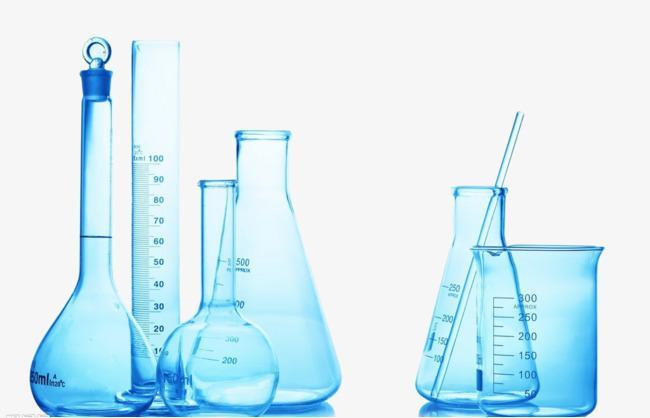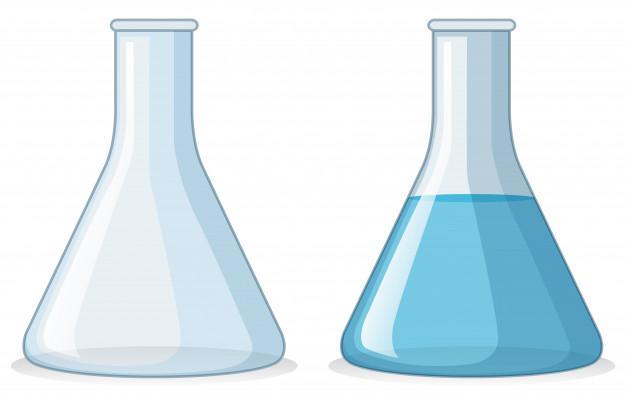The first image is the image on the left, the second image is the image on the right. Given the left and right images, does the statement "The right image includes a cylindrical container of blue liquid, and the left image features exactly one container." hold true? Answer yes or no. No. The first image is the image on the left, the second image is the image on the right. For the images shown, is this caption "The left and right image contains the same number of beakers." true? Answer yes or no. No. 